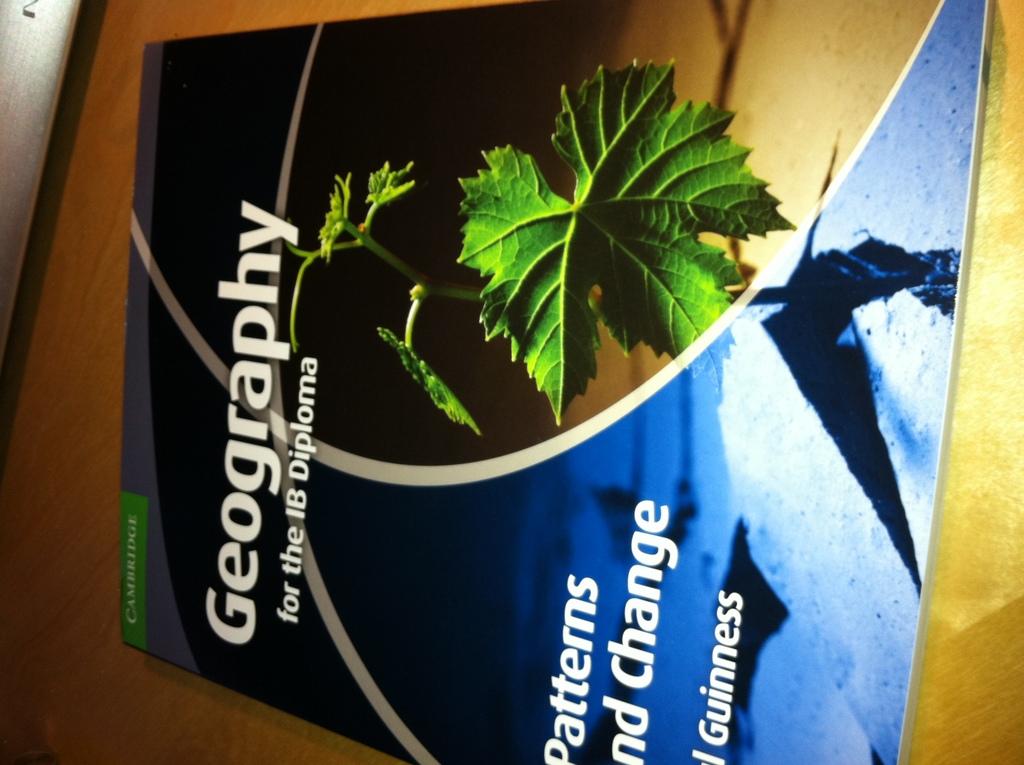What is the topic of this book?
Provide a succinct answer. Geography. Does the plant indicate a geographical study?
Keep it short and to the point. Unanswerable. 